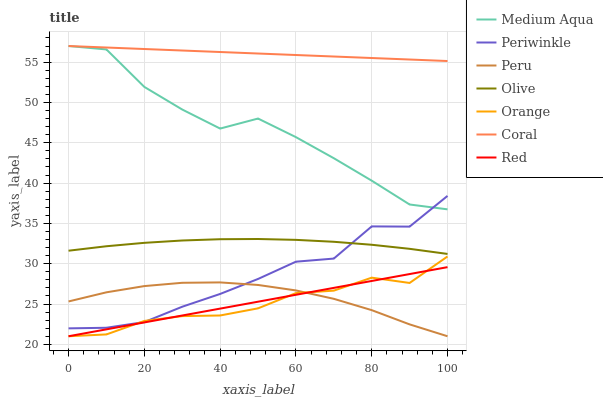Does Orange have the minimum area under the curve?
Answer yes or no. Yes. Does Coral have the maximum area under the curve?
Answer yes or no. Yes. Does Periwinkle have the minimum area under the curve?
Answer yes or no. No. Does Periwinkle have the maximum area under the curve?
Answer yes or no. No. Is Red the smoothest?
Answer yes or no. Yes. Is Medium Aqua the roughest?
Answer yes or no. Yes. Is Orange the smoothest?
Answer yes or no. No. Is Orange the roughest?
Answer yes or no. No. Does Orange have the lowest value?
Answer yes or no. Yes. Does Periwinkle have the lowest value?
Answer yes or no. No. Does Medium Aqua have the highest value?
Answer yes or no. Yes. Does Orange have the highest value?
Answer yes or no. No. Is Peru less than Coral?
Answer yes or no. Yes. Is Coral greater than Peru?
Answer yes or no. Yes. Does Orange intersect Red?
Answer yes or no. Yes. Is Orange less than Red?
Answer yes or no. No. Is Orange greater than Red?
Answer yes or no. No. Does Peru intersect Coral?
Answer yes or no. No. 